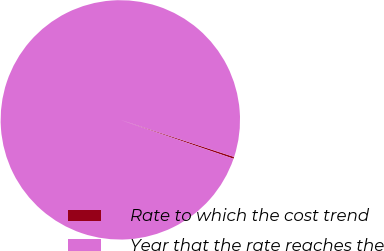<chart> <loc_0><loc_0><loc_500><loc_500><pie_chart><fcel>Rate to which the cost trend<fcel>Year that the rate reaches the<nl><fcel>0.25%<fcel>99.75%<nl></chart> 